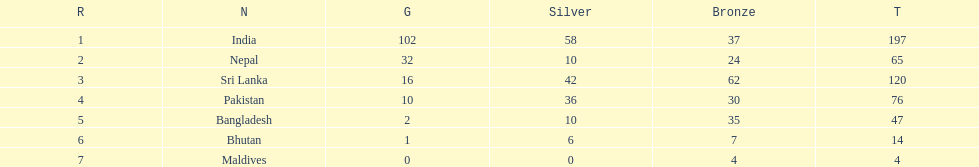What are the total number of bronze medals sri lanka have earned? 62. 